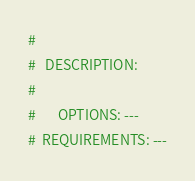<code> <loc_0><loc_0><loc_500><loc_500><_Bash_># 
#   DESCRIPTION: 
# 
#       OPTIONS: ---
#  REQUIREMENTS: ---</code> 